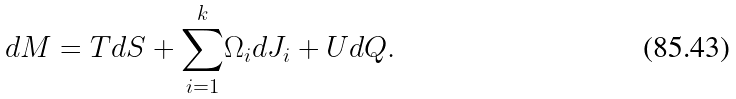<formula> <loc_0><loc_0><loc_500><loc_500>d M = T d S + { { { \sum _ { i = 1 } ^ { k } } } } \Omega _ { i } d J _ { i } + U d Q .</formula> 